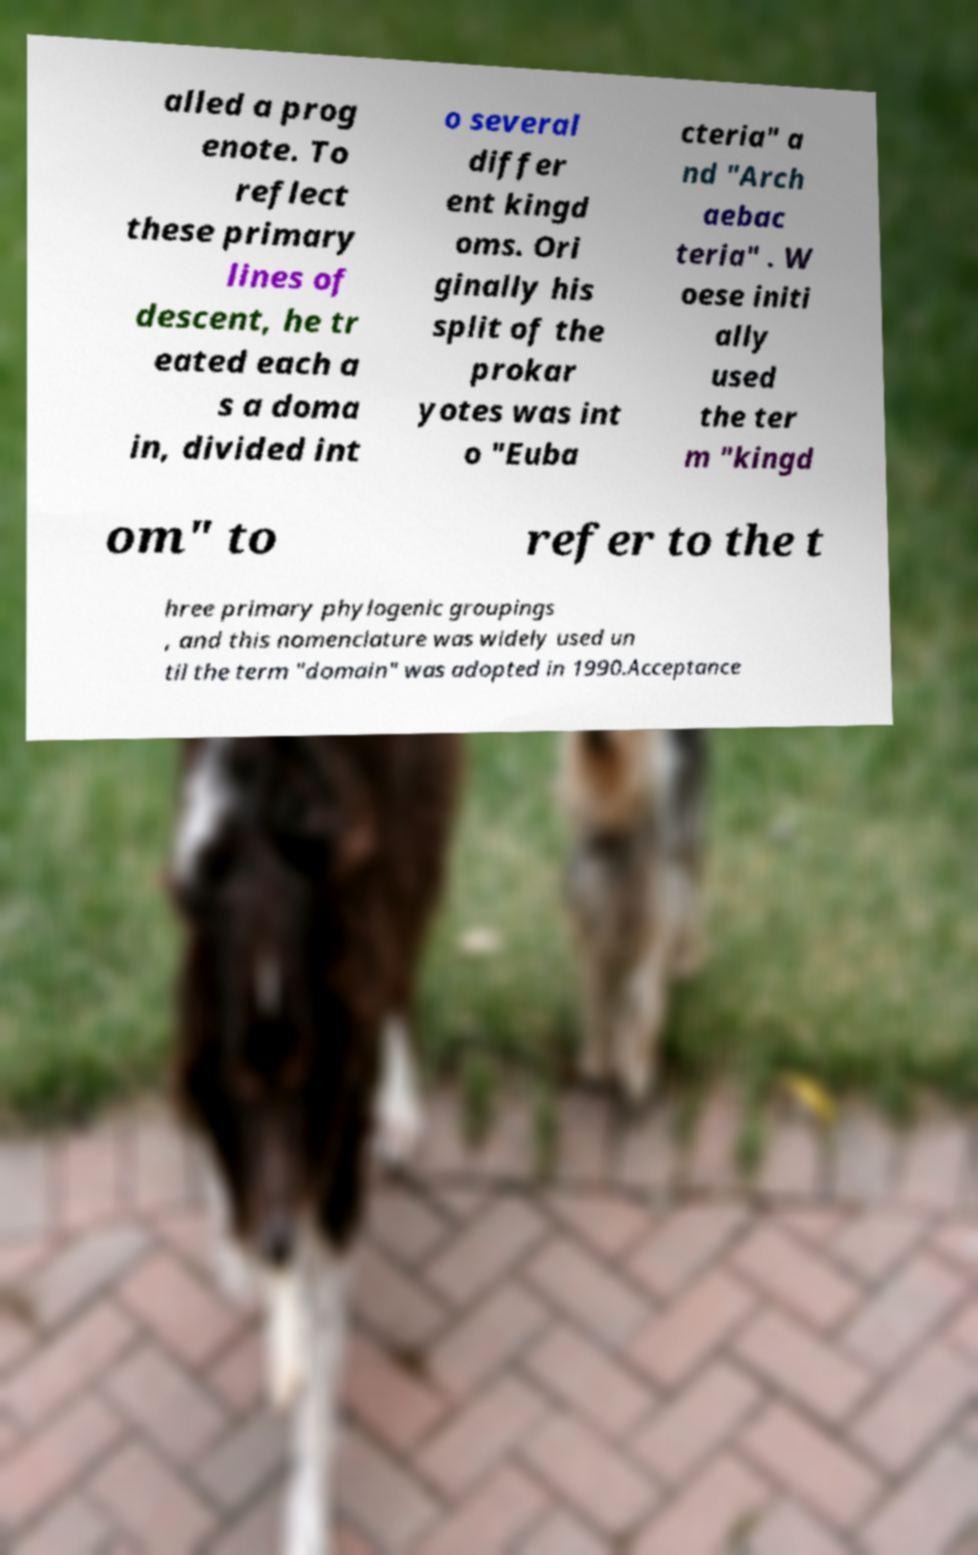Could you assist in decoding the text presented in this image and type it out clearly? alled a prog enote. To reflect these primary lines of descent, he tr eated each a s a doma in, divided int o several differ ent kingd oms. Ori ginally his split of the prokar yotes was int o "Euba cteria" a nd "Arch aebac teria" . W oese initi ally used the ter m "kingd om" to refer to the t hree primary phylogenic groupings , and this nomenclature was widely used un til the term "domain" was adopted in 1990.Acceptance 